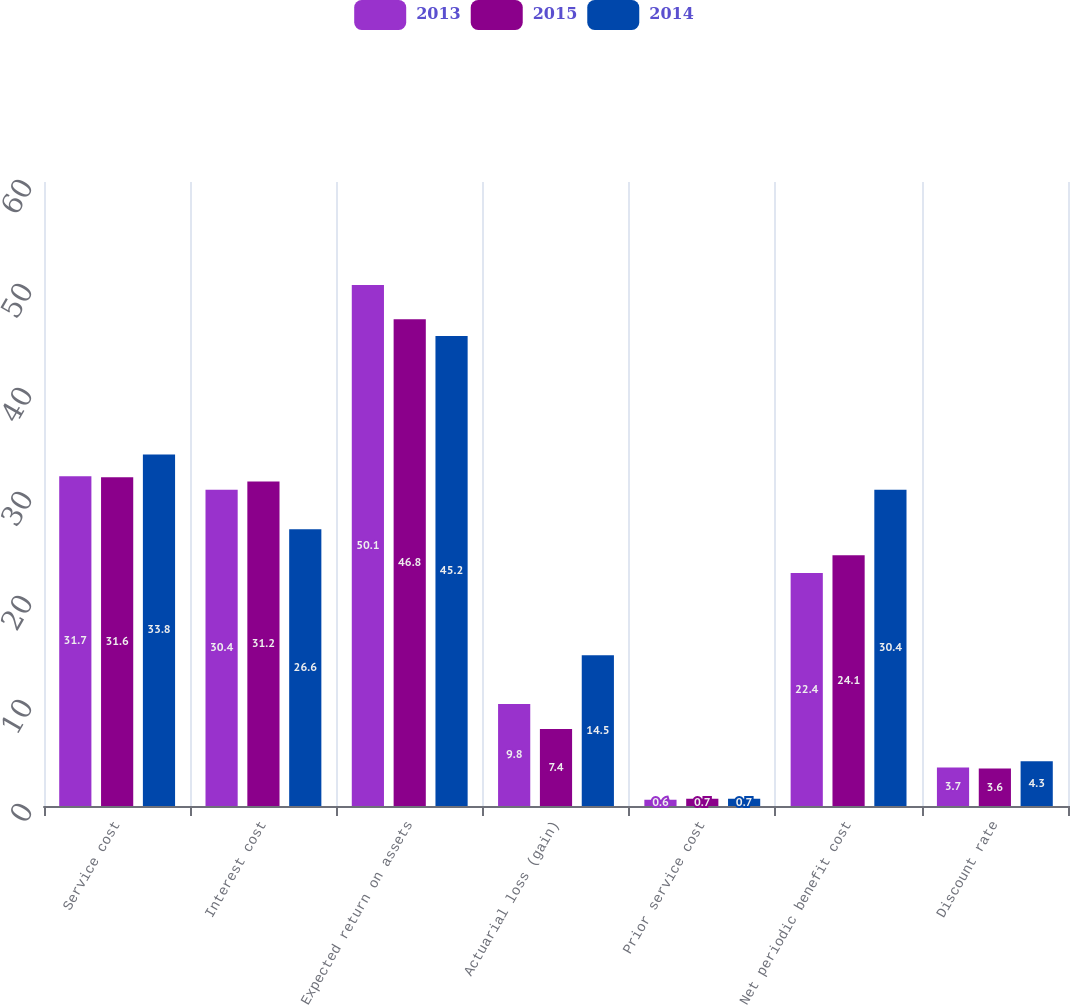Convert chart. <chart><loc_0><loc_0><loc_500><loc_500><stacked_bar_chart><ecel><fcel>Service cost<fcel>Interest cost<fcel>Expected return on assets<fcel>Actuarial loss (gain)<fcel>Prior service cost<fcel>Net periodic benefit cost<fcel>Discount rate<nl><fcel>2013<fcel>31.7<fcel>30.4<fcel>50.1<fcel>9.8<fcel>0.6<fcel>22.4<fcel>3.7<nl><fcel>2015<fcel>31.6<fcel>31.2<fcel>46.8<fcel>7.4<fcel>0.7<fcel>24.1<fcel>3.6<nl><fcel>2014<fcel>33.8<fcel>26.6<fcel>45.2<fcel>14.5<fcel>0.7<fcel>30.4<fcel>4.3<nl></chart> 